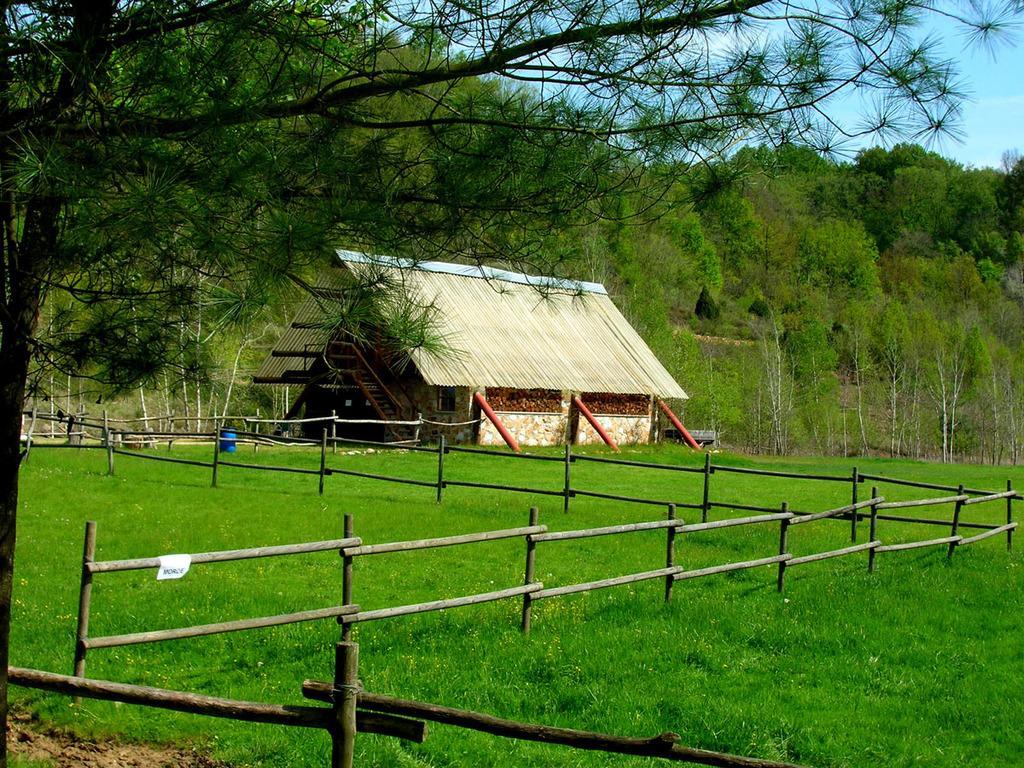Could you give a brief overview of what you see in this image? This image consists of a hut. At the bottom, there is green grass. And there is a fencing made up of wood. In the background, there are trees. 